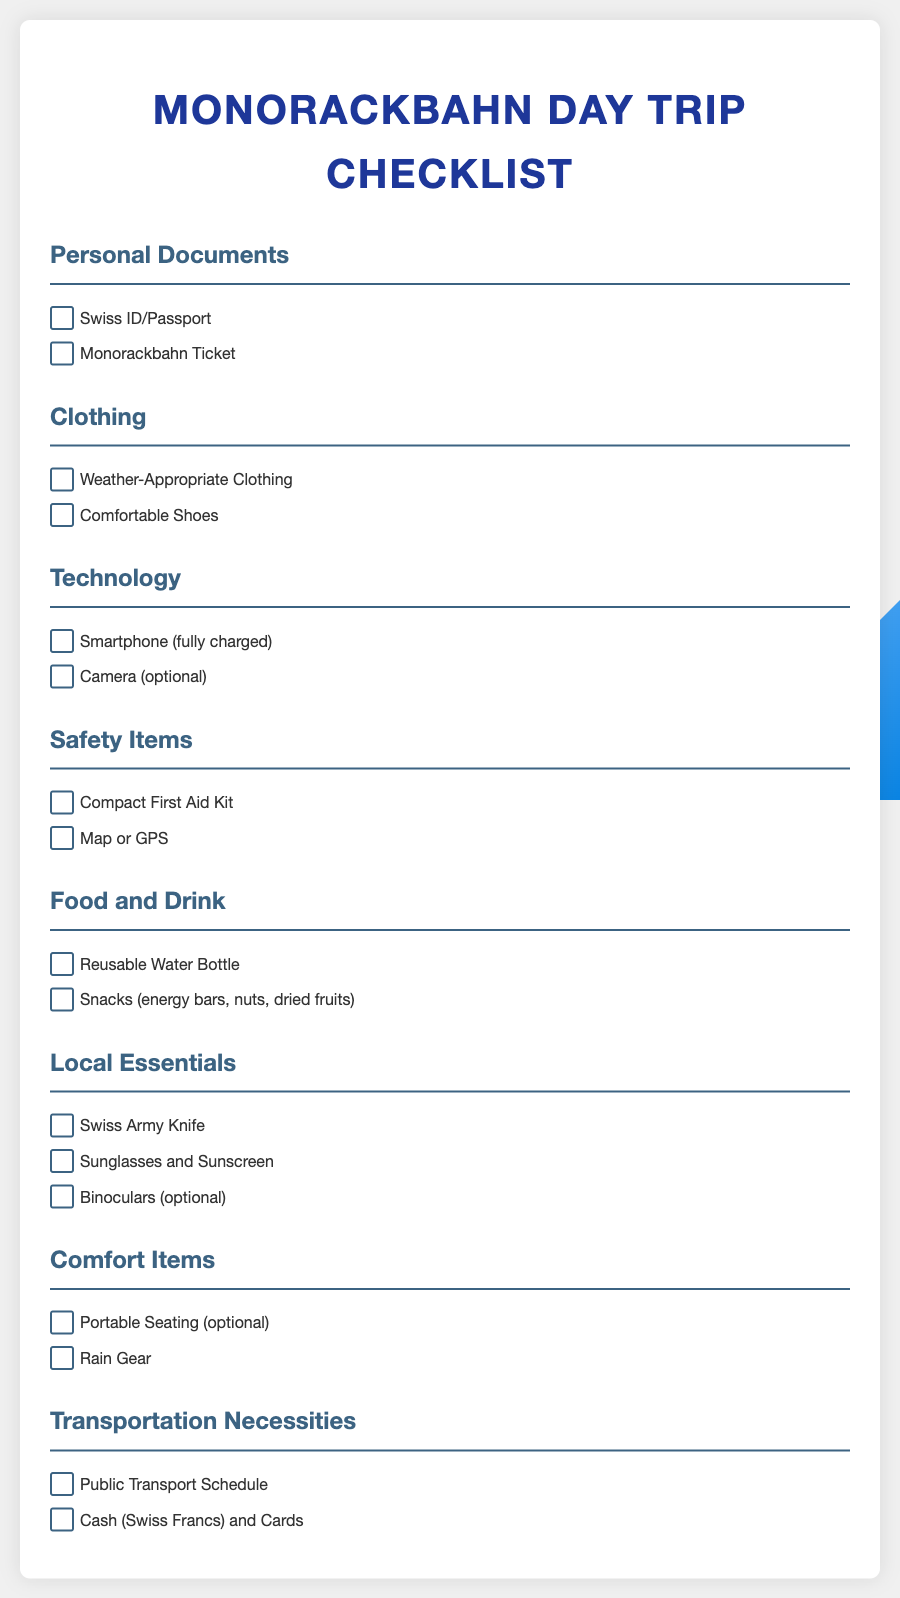what are the two personal documents listed? The checklist includes "Swiss ID/Passport" and "Monorackbahn Ticket" under Personal Documents.
Answer: Swiss ID/Passport, Monorackbahn Ticket how many items are listed under Clothing? There are two items mentioned in the Clothing section which are "Weather-Appropriate Clothing" and "Comfortable Shoes".
Answer: 2 what item is optional under Technology? The Technology section includes "Camera" as an optional item.
Answer: Camera how many items are listed under Safety Items? The Safety Items section contains two entries: "Compact First Aid Kit" and "Map or GPS".
Answer: 2 what essential item is mentioned for food and drink? The checklist specifies "Reusable Water Bottle" as an essential item under Food and Drink.
Answer: Reusable Water Bottle which tool is included under Local Essentials? "Swiss Army Knife" is the tool listed under Local Essentials.
Answer: Swiss Army Knife what item is listed as optional under Comfort Items? The checklist states "Portable Seating" as an optional item in the Comfort Items section.
Answer: Portable Seating what necessity is mentioned for transportation? "Public Transport Schedule" is listed as a necessity under Transportation Necessities.
Answer: Public Transport Schedule 